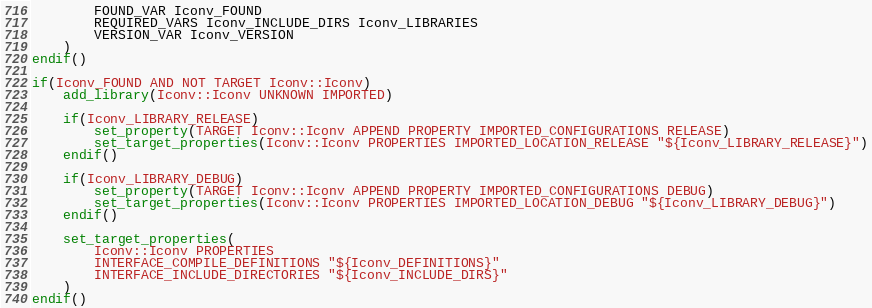<code> <loc_0><loc_0><loc_500><loc_500><_CMake_>		FOUND_VAR Iconv_FOUND
		REQUIRED_VARS Iconv_INCLUDE_DIRS Iconv_LIBRARIES
		VERSION_VAR Iconv_VERSION
	)
endif()

if(Iconv_FOUND AND NOT TARGET Iconv::Iconv)
	add_library(Iconv::Iconv UNKNOWN IMPORTED)
	
	if(Iconv_LIBRARY_RELEASE)
		set_property(TARGET Iconv::Iconv APPEND PROPERTY IMPORTED_CONFIGURATIONS RELEASE)
		set_target_properties(Iconv::Iconv PROPERTIES IMPORTED_LOCATION_RELEASE "${Iconv_LIBRARY_RELEASE}")
	endif()
	
	if(Iconv_LIBRARY_DEBUG)
		set_property(TARGET Iconv::Iconv APPEND PROPERTY IMPORTED_CONFIGURATIONS DEBUG)
		set_target_properties(Iconv::Iconv PROPERTIES IMPORTED_LOCATION_DEBUG "${Iconv_LIBRARY_DEBUG}")
	endif()
	
	set_target_properties(
		Iconv::Iconv PROPERTIES
		INTERFACE_COMPILE_DEFINITIONS "${Iconv_DEFINITIONS}"
		INTERFACE_INCLUDE_DIRECTORIES "${Iconv_INCLUDE_DIRS}"
	)
endif()
</code> 